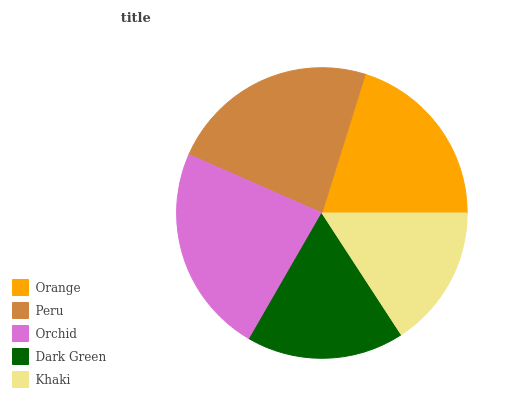Is Khaki the minimum?
Answer yes or no. Yes. Is Orchid the maximum?
Answer yes or no. Yes. Is Peru the minimum?
Answer yes or no. No. Is Peru the maximum?
Answer yes or no. No. Is Peru greater than Orange?
Answer yes or no. Yes. Is Orange less than Peru?
Answer yes or no. Yes. Is Orange greater than Peru?
Answer yes or no. No. Is Peru less than Orange?
Answer yes or no. No. Is Orange the high median?
Answer yes or no. Yes. Is Orange the low median?
Answer yes or no. Yes. Is Dark Green the high median?
Answer yes or no. No. Is Orchid the low median?
Answer yes or no. No. 